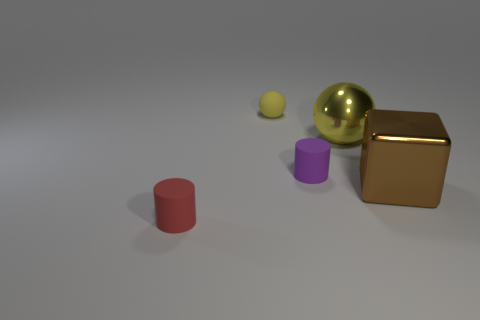There is a shiny object that is behind the purple cylinder in front of the metallic object left of the shiny cube; what is its size?
Ensure brevity in your answer.  Large. There is a purple object that is the same size as the yellow rubber ball; what is its material?
Your answer should be compact. Rubber. Is there a blue cube that has the same size as the purple rubber cylinder?
Keep it short and to the point. No. Is the size of the yellow sphere that is in front of the matte sphere the same as the large brown thing?
Offer a terse response. Yes. What is the shape of the object that is both left of the large yellow object and behind the tiny purple matte thing?
Ensure brevity in your answer.  Sphere. Is the number of shiny things to the left of the red matte cylinder greater than the number of big yellow things?
Give a very brief answer. No. What is the size of the red object that is made of the same material as the tiny purple cylinder?
Provide a short and direct response. Small. What number of other large cubes have the same color as the big cube?
Your answer should be compact. 0. Does the big shiny block on the right side of the tiny yellow sphere have the same color as the rubber sphere?
Provide a short and direct response. No. Is the number of large metal objects that are behind the purple thing the same as the number of tiny yellow things that are in front of the brown object?
Offer a very short reply. No. 